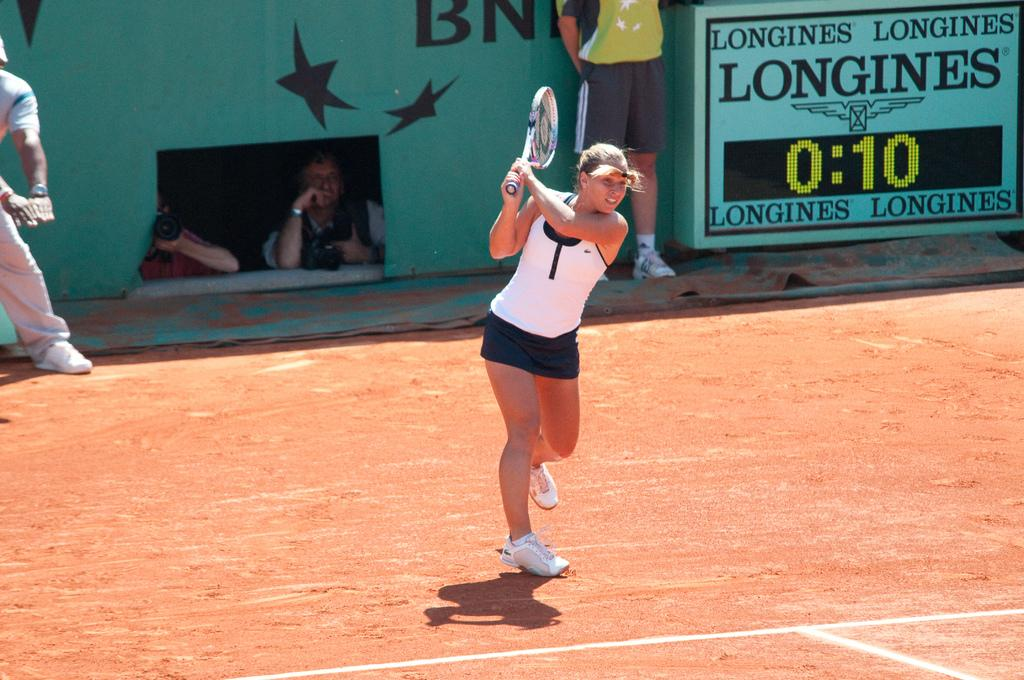Who is the main subject in the image? There is a woman in the image. What is the woman holding in the image? The woman is holding a tennis bat. Are there any other people visible in the image? Yes, there are people behind the woman. What is the rate of the planes flying in the image? There are no planes visible in the image, so it is not possible to determine the rate at which they might be flying. 